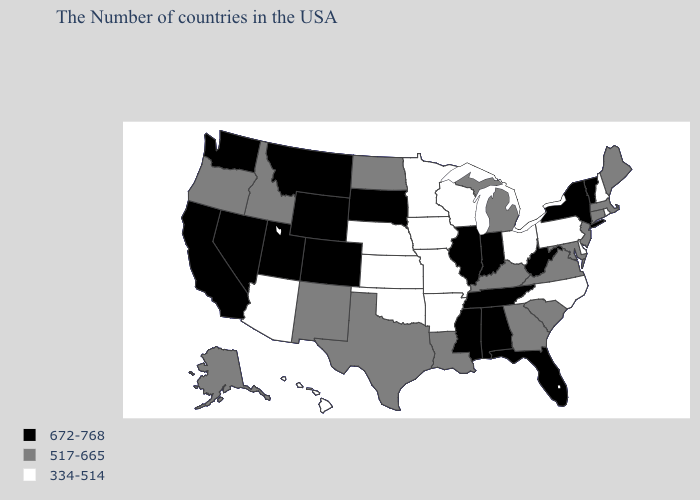How many symbols are there in the legend?
Quick response, please. 3. Which states have the highest value in the USA?
Give a very brief answer. Vermont, New York, West Virginia, Florida, Indiana, Alabama, Tennessee, Illinois, Mississippi, South Dakota, Wyoming, Colorado, Utah, Montana, Nevada, California, Washington. What is the highest value in the Northeast ?
Give a very brief answer. 672-768. Which states have the lowest value in the South?
Give a very brief answer. Delaware, North Carolina, Arkansas, Oklahoma. Name the states that have a value in the range 334-514?
Quick response, please. Rhode Island, New Hampshire, Delaware, Pennsylvania, North Carolina, Ohio, Wisconsin, Missouri, Arkansas, Minnesota, Iowa, Kansas, Nebraska, Oklahoma, Arizona, Hawaii. Name the states that have a value in the range 517-665?
Give a very brief answer. Maine, Massachusetts, Connecticut, New Jersey, Maryland, Virginia, South Carolina, Georgia, Michigan, Kentucky, Louisiana, Texas, North Dakota, New Mexico, Idaho, Oregon, Alaska. What is the lowest value in the West?
Answer briefly. 334-514. Name the states that have a value in the range 334-514?
Be succinct. Rhode Island, New Hampshire, Delaware, Pennsylvania, North Carolina, Ohio, Wisconsin, Missouri, Arkansas, Minnesota, Iowa, Kansas, Nebraska, Oklahoma, Arizona, Hawaii. Among the states that border Arizona , does Colorado have the lowest value?
Quick response, please. No. How many symbols are there in the legend?
Keep it brief. 3. Does Massachusetts have a higher value than New Jersey?
Quick response, please. No. Name the states that have a value in the range 517-665?
Answer briefly. Maine, Massachusetts, Connecticut, New Jersey, Maryland, Virginia, South Carolina, Georgia, Michigan, Kentucky, Louisiana, Texas, North Dakota, New Mexico, Idaho, Oregon, Alaska. What is the highest value in states that border Pennsylvania?
Be succinct. 672-768. Which states have the lowest value in the USA?
Short answer required. Rhode Island, New Hampshire, Delaware, Pennsylvania, North Carolina, Ohio, Wisconsin, Missouri, Arkansas, Minnesota, Iowa, Kansas, Nebraska, Oklahoma, Arizona, Hawaii. What is the value of Virginia?
Write a very short answer. 517-665. 